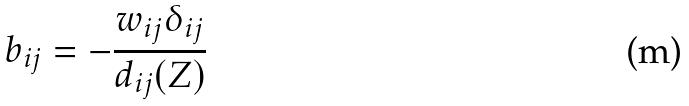Convert formula to latex. <formula><loc_0><loc_0><loc_500><loc_500>b _ { i j } = - \frac { w _ { i j } \delta _ { i j } } { d _ { i j } ( Z ) }</formula> 